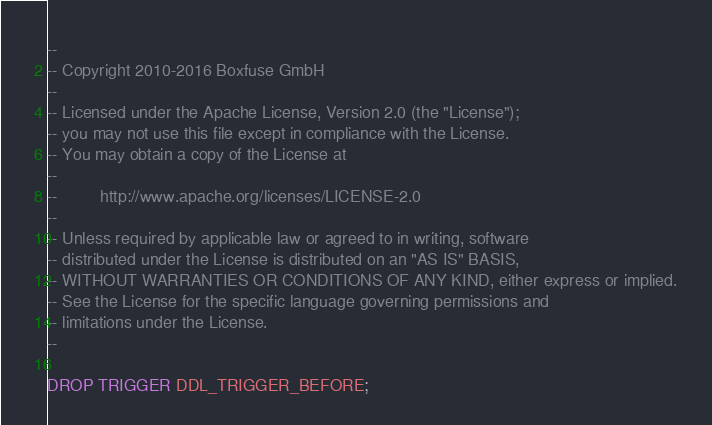<code> <loc_0><loc_0><loc_500><loc_500><_SQL_>--
-- Copyright 2010-2016 Boxfuse GmbH
--
-- Licensed under the Apache License, Version 2.0 (the "License");
-- you may not use this file except in compliance with the License.
-- You may obtain a copy of the License at
--
--         http://www.apache.org/licenses/LICENSE-2.0
--
-- Unless required by applicable law or agreed to in writing, software
-- distributed under the License is distributed on an "AS IS" BASIS,
-- WITHOUT WARRANTIES OR CONDITIONS OF ANY KIND, either express or implied.
-- See the License for the specific language governing permissions and
-- limitations under the License.
--

DROP TRIGGER DDL_TRIGGER_BEFORE;
</code> 